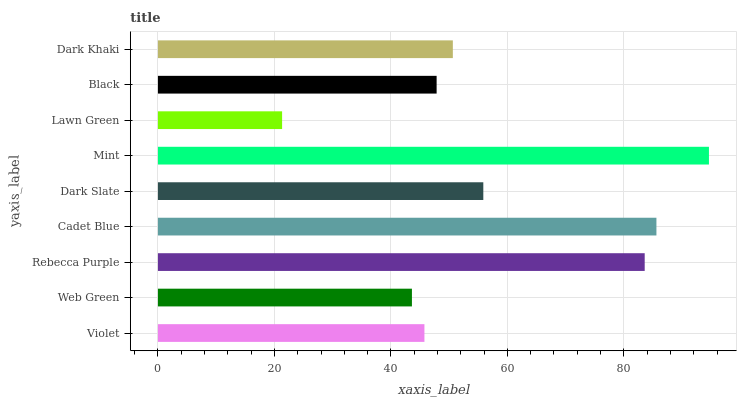Is Lawn Green the minimum?
Answer yes or no. Yes. Is Mint the maximum?
Answer yes or no. Yes. Is Web Green the minimum?
Answer yes or no. No. Is Web Green the maximum?
Answer yes or no. No. Is Violet greater than Web Green?
Answer yes or no. Yes. Is Web Green less than Violet?
Answer yes or no. Yes. Is Web Green greater than Violet?
Answer yes or no. No. Is Violet less than Web Green?
Answer yes or no. No. Is Dark Khaki the high median?
Answer yes or no. Yes. Is Dark Khaki the low median?
Answer yes or no. Yes. Is Lawn Green the high median?
Answer yes or no. No. Is Web Green the low median?
Answer yes or no. No. 